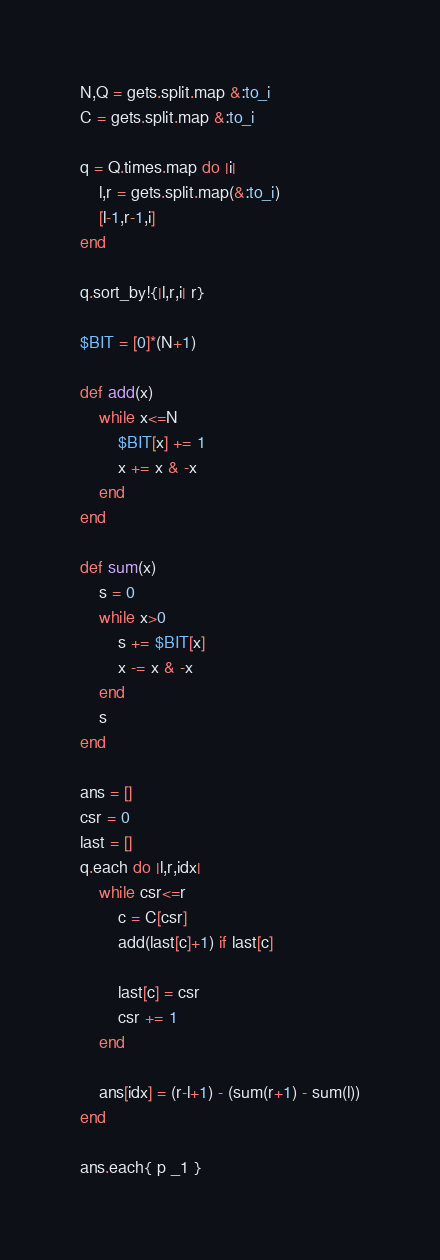<code> <loc_0><loc_0><loc_500><loc_500><_Ruby_>N,Q = gets.split.map &:to_i
C = gets.split.map &:to_i

q = Q.times.map do |i| 
    l,r = gets.split.map(&:to_i)
    [l-1,r-1,i]
end
    
q.sort_by!{|l,r,i| r}

$BIT = [0]*(N+1)

def add(x)
    while x<=N
        $BIT[x] += 1
        x += x & -x
    end
end

def sum(x)
    s = 0
    while x>0
        s += $BIT[x]
        x -= x & -x
    end
    s
end

ans = []
csr = 0
last = []
q.each do |l,r,idx|
    while csr<=r
        c = C[csr]
        add(last[c]+1) if last[c]

        last[c] = csr
        csr += 1
    end

    ans[idx] = (r-l+1) - (sum(r+1) - sum(l))
end

ans.each{ p _1 }</code> 